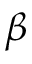Convert formula to latex. <formula><loc_0><loc_0><loc_500><loc_500>\beta</formula> 